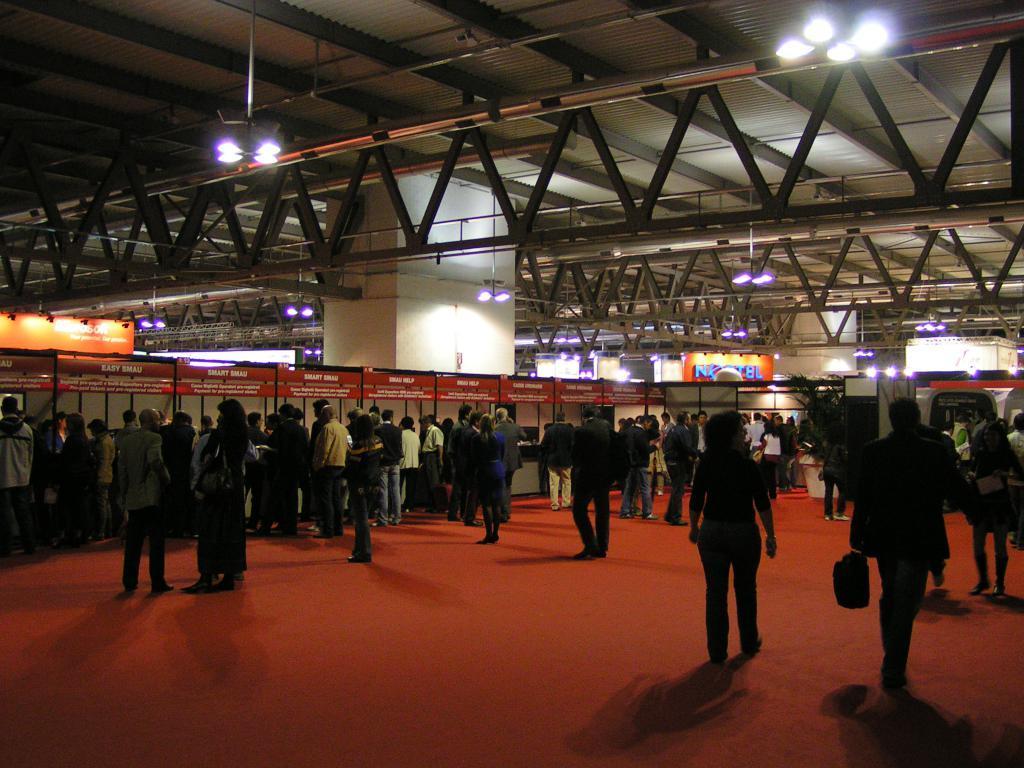Can you describe this image briefly? In this picture we can see a group of people standing and some people are walking on the floor and in the background we can see the lights, posters, pillar, roof and some objects. 